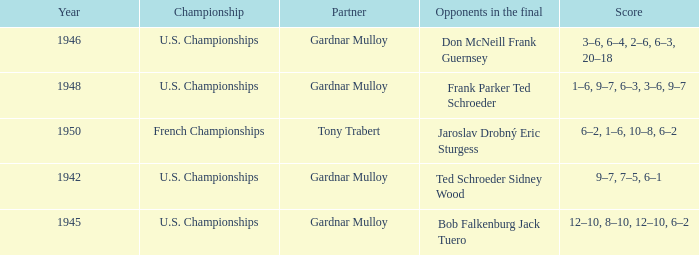Which opponents in the u.s. championships played after 1945 and had a score of 3–6, 6–4, 2–6, 6–3, 20–18? Don McNeill Frank Guernsey. 